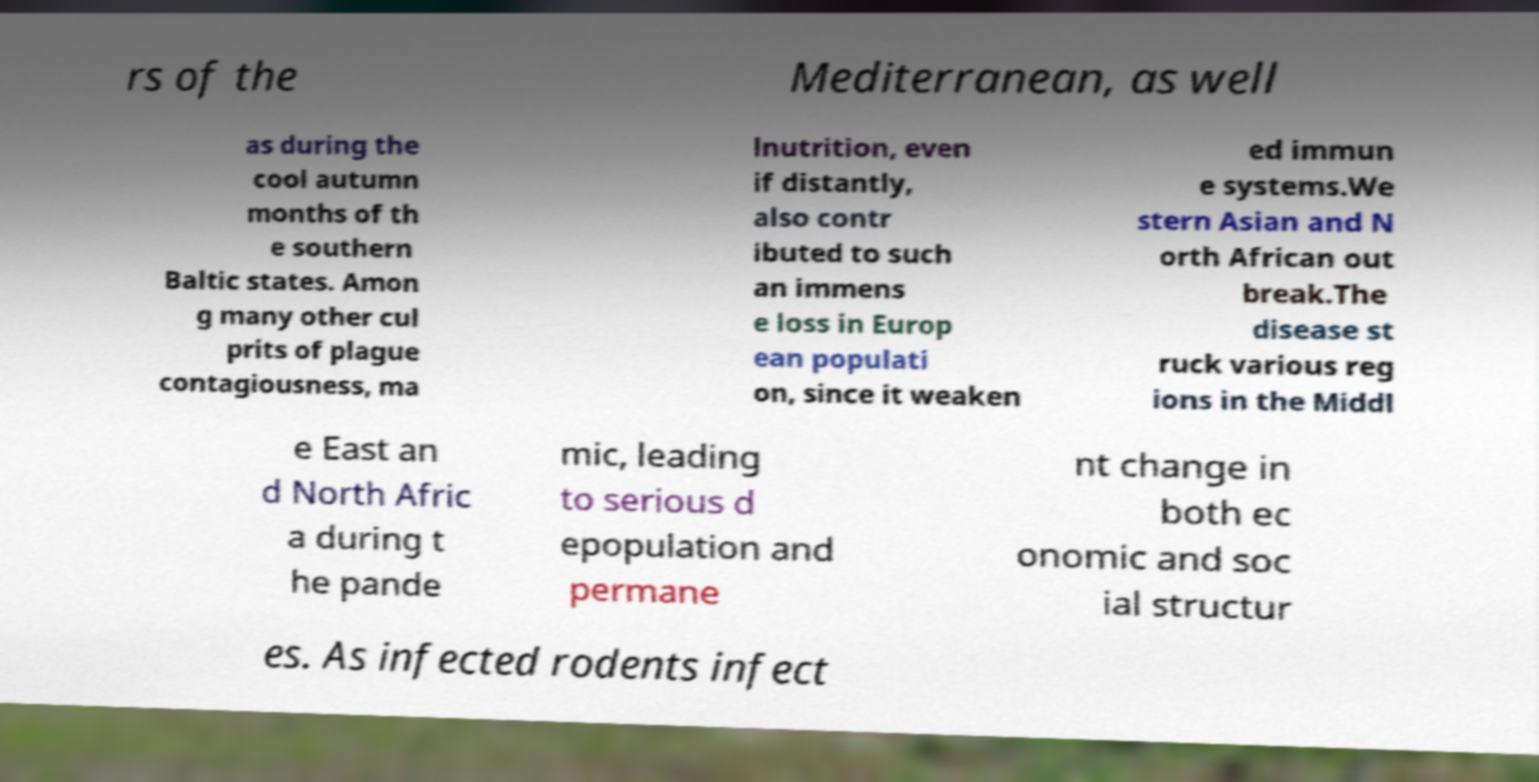There's text embedded in this image that I need extracted. Can you transcribe it verbatim? rs of the Mediterranean, as well as during the cool autumn months of th e southern Baltic states. Amon g many other cul prits of plague contagiousness, ma lnutrition, even if distantly, also contr ibuted to such an immens e loss in Europ ean populati on, since it weaken ed immun e systems.We stern Asian and N orth African out break.The disease st ruck various reg ions in the Middl e East an d North Afric a during t he pande mic, leading to serious d epopulation and permane nt change in both ec onomic and soc ial structur es. As infected rodents infect 